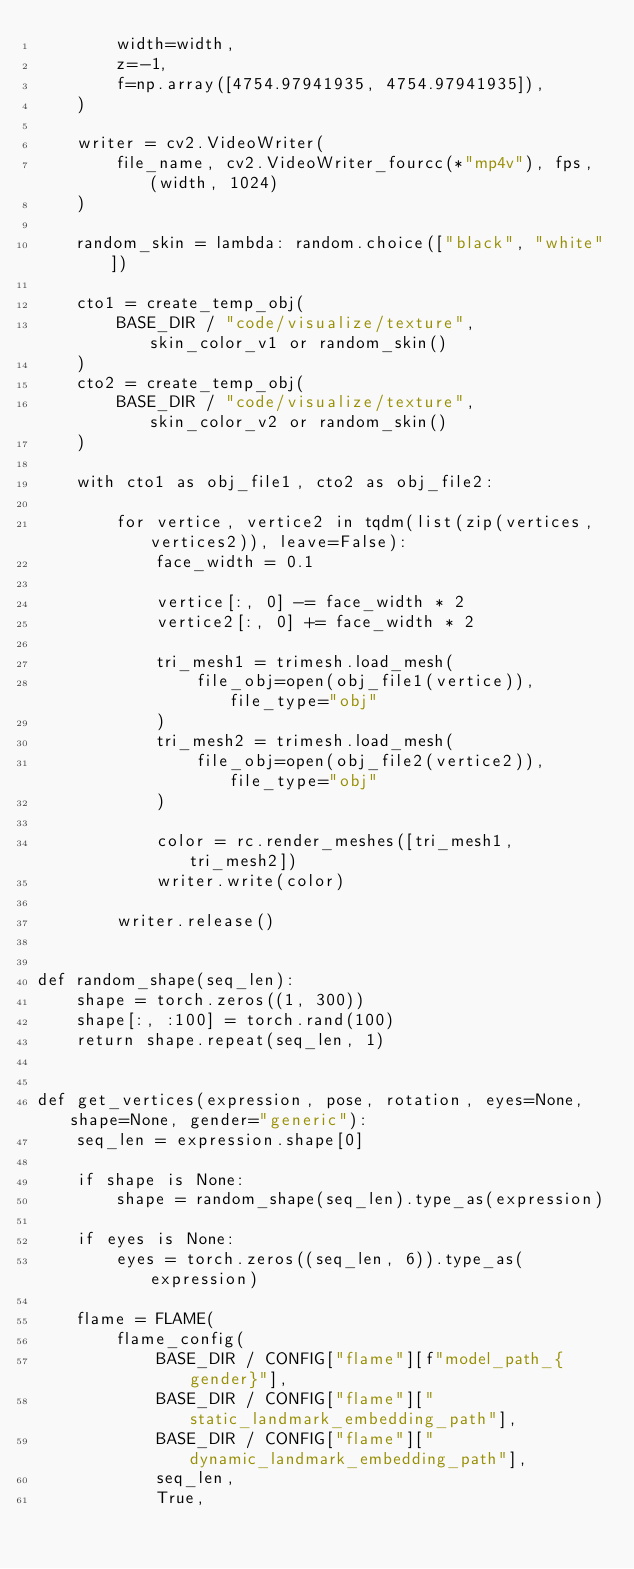<code> <loc_0><loc_0><loc_500><loc_500><_Python_>        width=width,
        z=-1,
        f=np.array([4754.97941935, 4754.97941935]),
    )

    writer = cv2.VideoWriter(
        file_name, cv2.VideoWriter_fourcc(*"mp4v"), fps, (width, 1024)
    )

    random_skin = lambda: random.choice(["black", "white"])

    cto1 = create_temp_obj(
        BASE_DIR / "code/visualize/texture", skin_color_v1 or random_skin()
    )
    cto2 = create_temp_obj(
        BASE_DIR / "code/visualize/texture", skin_color_v2 or random_skin()
    )

    with cto1 as obj_file1, cto2 as obj_file2:

        for vertice, vertice2 in tqdm(list(zip(vertices, vertices2)), leave=False):
            face_width = 0.1

            vertice[:, 0] -= face_width * 2
            vertice2[:, 0] += face_width * 2

            tri_mesh1 = trimesh.load_mesh(
                file_obj=open(obj_file1(vertice)), file_type="obj"
            )
            tri_mesh2 = trimesh.load_mesh(
                file_obj=open(obj_file2(vertice2)), file_type="obj"
            )

            color = rc.render_meshes([tri_mesh1, tri_mesh2])
            writer.write(color)

        writer.release()


def random_shape(seq_len):
    shape = torch.zeros((1, 300))
    shape[:, :100] = torch.rand(100)
    return shape.repeat(seq_len, 1)


def get_vertices(expression, pose, rotation, eyes=None, shape=None, gender="generic"):
    seq_len = expression.shape[0]

    if shape is None:
        shape = random_shape(seq_len).type_as(expression)

    if eyes is None:
        eyes = torch.zeros((seq_len, 6)).type_as(expression)

    flame = FLAME(
        flame_config(
            BASE_DIR / CONFIG["flame"][f"model_path_{gender}"],
            BASE_DIR / CONFIG["flame"]["static_landmark_embedding_path"],
            BASE_DIR / CONFIG["flame"]["dynamic_landmark_embedding_path"],
            seq_len,
            True,</code> 